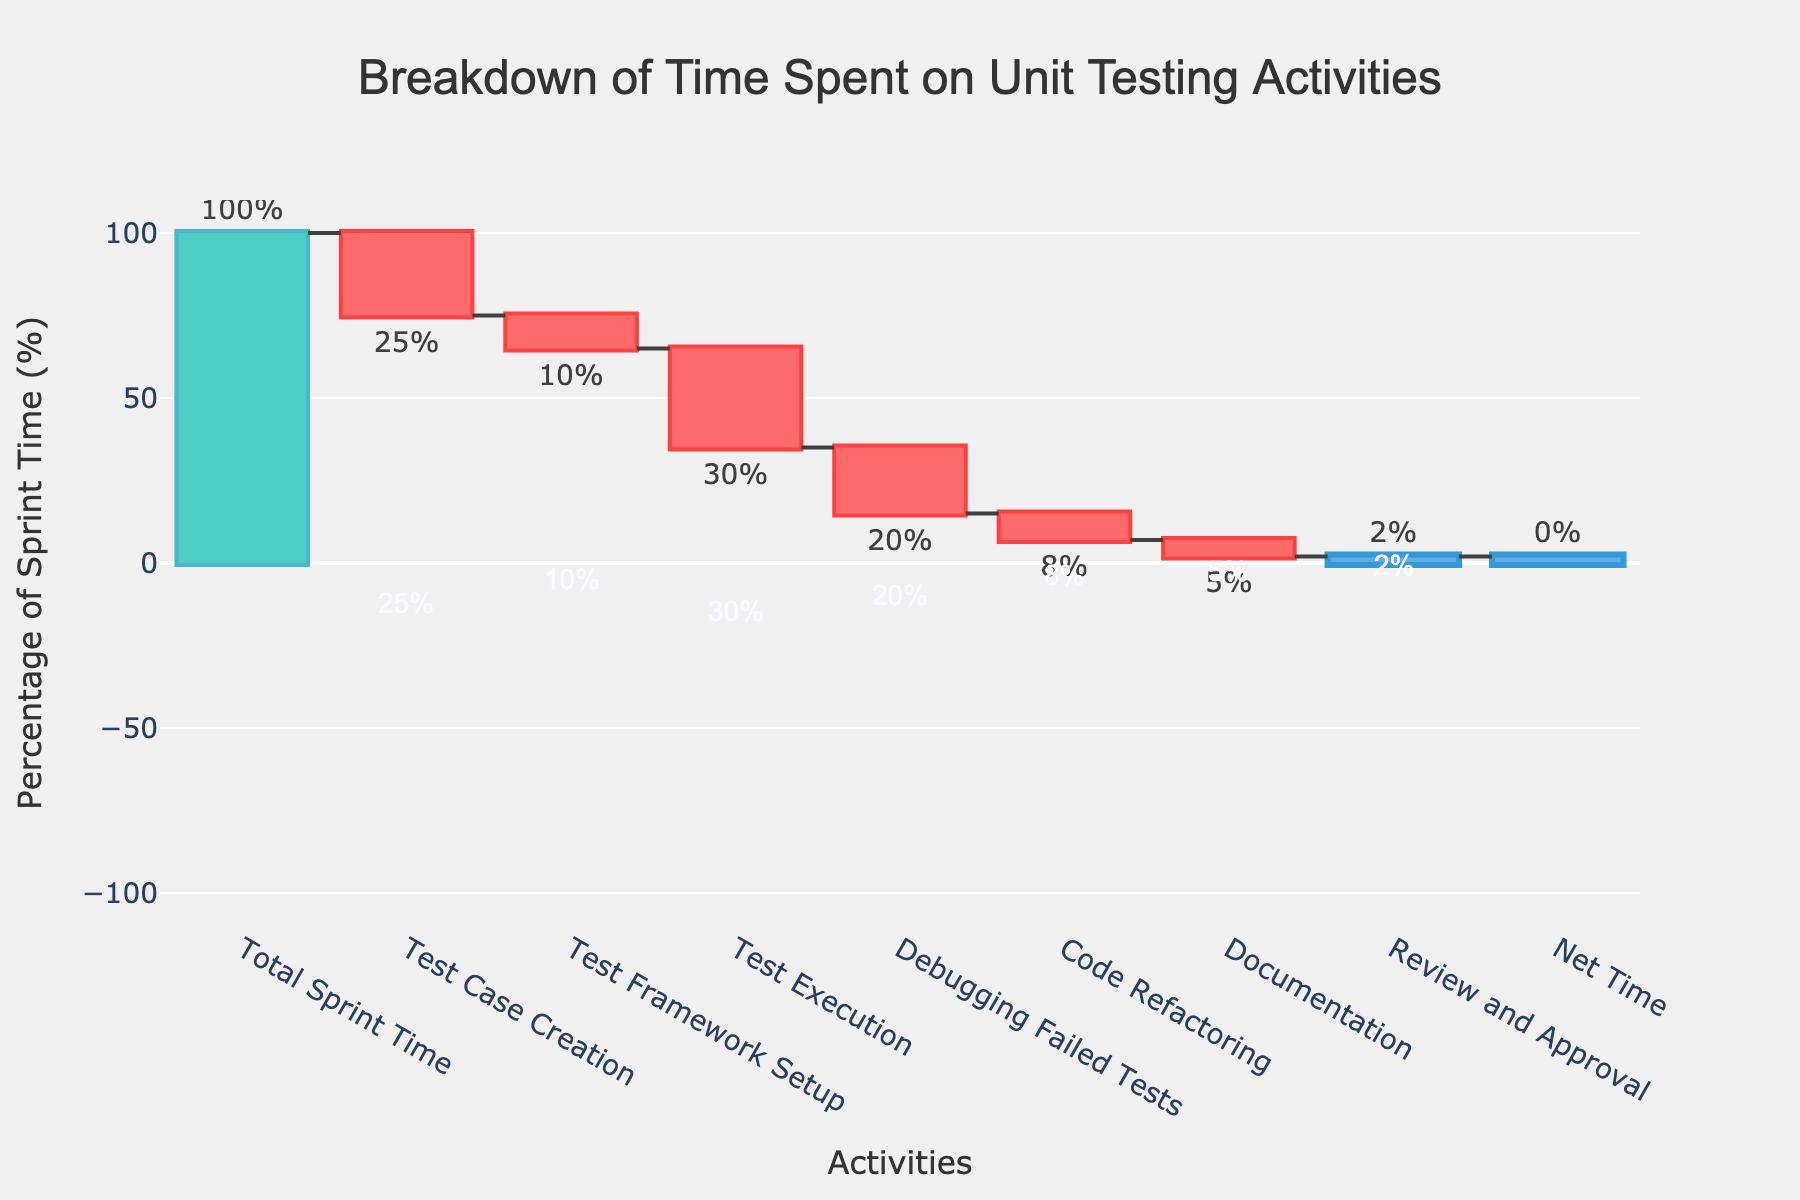What is the title of the waterfall chart? The title is located at the top of the chart. It reads "Breakdown of Time Spent on Unit Testing Activities". The title provides the main context of the data depicted in the chart.
Answer: "Breakdown of Time Spent on Unit Testing Activities" What is the percentage of sprint time spent on test case creation? The bar for "Test Case Creation" shows a negative percentage, which indicates time taken from the total sprint time. The corresponding value displayed on the bar is "-25%". Therefore, 25% of the total sprint time is spent on test case creation.
Answer: 25% Which activity uses the least sprint time according to the chart, and what is its percentage? By observing the lengths of the bars and their values, "Review and Approval" has the smallest bar with a value of "-2%". This indicates it uses the least amount of time in the sprint.
Answer: Review and Approval, 2% What is the net time remaining at the end of all unit testing activities? The net time is represented by the last bar labeled "Net Time". According to the bar, the value at the net time bar is "0%", meaning the net time remaining is zero.
Answer: 0% Between test execution and debugging failed tests, which activity took more sprint time and by how much? Test Execution and Debugging Failed Tests' bars are compared. Test Execution is at "-30%" and Debugging Failed Tests is at "-20%". By subtracting, it's clear that Test Execution took 30%-20% = 10% more sprint time.
Answer: Test Execution, 10% What is the combined percentage of sprint time spent on documentation and review and approval? Documentation has a value of "-5%" and Review and Approval has "-2%". Summing these two values gives the combined percentage: 5% + 2% = 7%.
Answer: 7% Is the total sprint time equal or different after accounting for all activities, and by how much? The chart indicates a "Total Sprint Time" starting at 100%, and a "Net Time" at the end showing 0%. Since Net Time is 0, it means all the sprint time has been accounted for with no difference, totaling the exact allotted time.
Answer: Equal, 0% Which activity among test case creation, test framework setup, and code refactoring took the most sprint time? The bars for "Test Case Creation", "Test Framework Setup", and "Code Refactoring" are compared. Test Case Creation shows "-25%", Test Framework Setup shows "-10%", and Code Refactoring shows "-8%". Test Case Creation took the most time at 25%.
Answer: Test Case Creation, 25% What is the total percentage of sprint time spent on all the activities combined before reaching net time? To find this, sum the absolute values of all individual activities before Net Time: 25% (Test Case Creation) + 10% (Test Framework Setup) + 30% (Test Execution) + 20% (Debugging Failed Tests) + 8% (Code Refactoring) + 5% (Documentation) + 2% (Review and Approval) = 100%.
Answer: 100% How much more time is spent on test execution compared to code refactoring? The value for Test Execution is "-30%" and for Code Refactoring is "-8%". Subtracting these values: 30% - 8% = 22%. Therefore, 22% more sprint time is spent on Test Execution compared to Code Refactoring.
Answer: 22% 